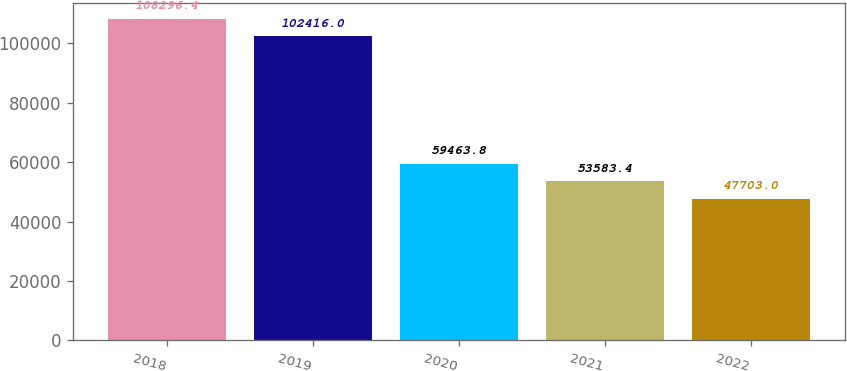Convert chart. <chart><loc_0><loc_0><loc_500><loc_500><bar_chart><fcel>2018<fcel>2019<fcel>2020<fcel>2021<fcel>2022<nl><fcel>108296<fcel>102416<fcel>59463.8<fcel>53583.4<fcel>47703<nl></chart> 